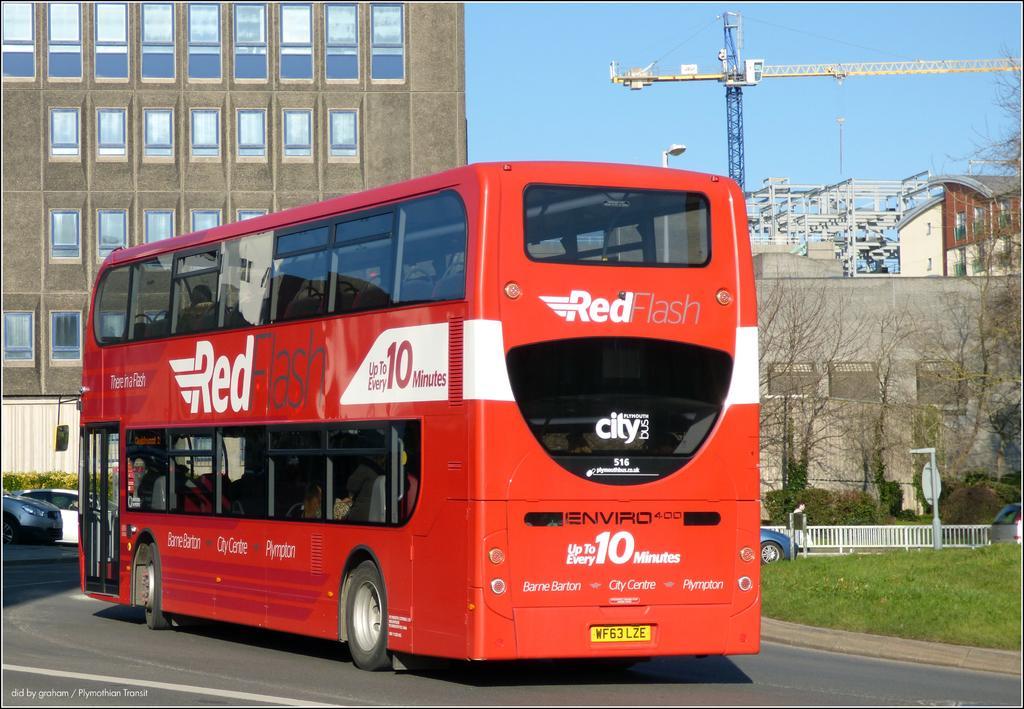Can you describe this image briefly? In this image we can see bus on the road. On the bus there is text. Near to the bus there are few vehicles. Also there is a railing. And there are trees. In the background there are buildings. And there is a crane. Also there are light poles. And there is sky. 